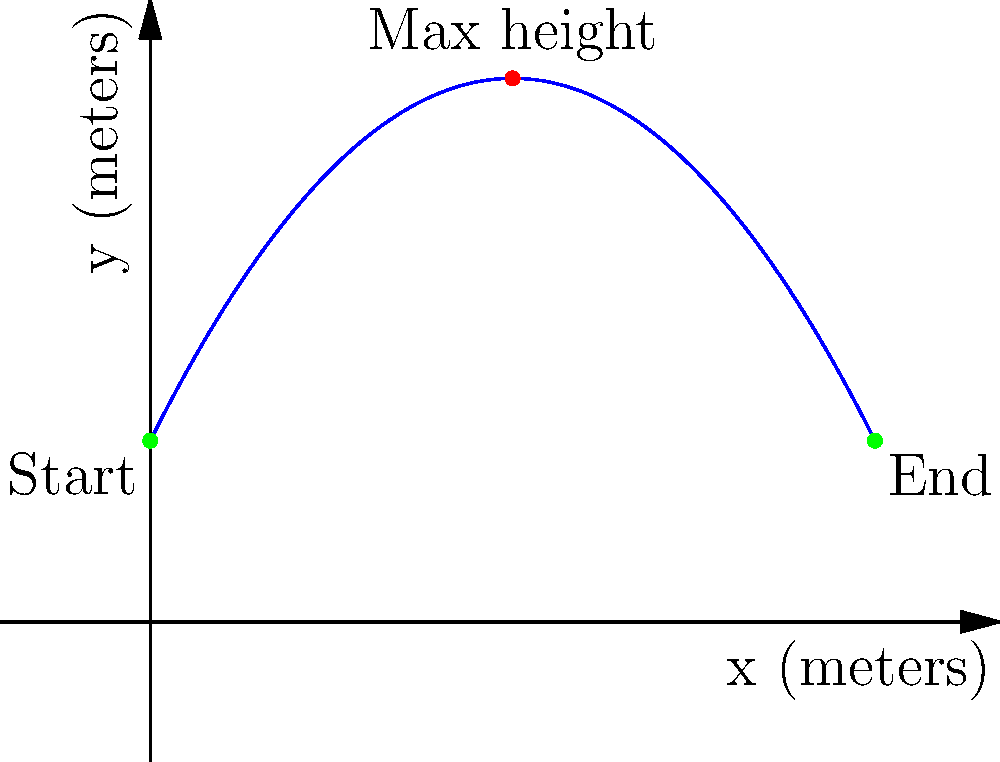During a memorable concert in 1962, Johnny Mathis dramatically throws his microphone in a perfect parabolic arc. The trajectory of the microphone can be modeled by the function $f(x) = -0.1x^2 + 2x + 5$, where $x$ is the horizontal distance in meters and $f(x)$ is the height in meters. What is the maximum height reached by the microphone during its flight? To find the maximum height of the parabolic trajectory, we need to follow these steps:

1) The parabola is given by the function $f(x) = -0.1x^2 + 2x + 5$.

2) For a parabola of the form $f(x) = ax^2 + bx + c$, the x-coordinate of the vertex is given by $x = -\frac{b}{2a}$.

3) In this case, $a = -0.1$ and $b = 2$. So:

   $x = -\frac{2}{2(-0.1)} = -\frac{2}{-0.2} = 10$

4) To find the maximum height, we need to calculate $f(10)$:

   $f(10) = -0.1(10)^2 + 2(10) + 5$
   $= -0.1(100) + 20 + 5$
   $= -10 + 20 + 5$
   $= 15$

5) Therefore, the maximum height reached by the microphone is 15 meters.
Answer: 15 meters 